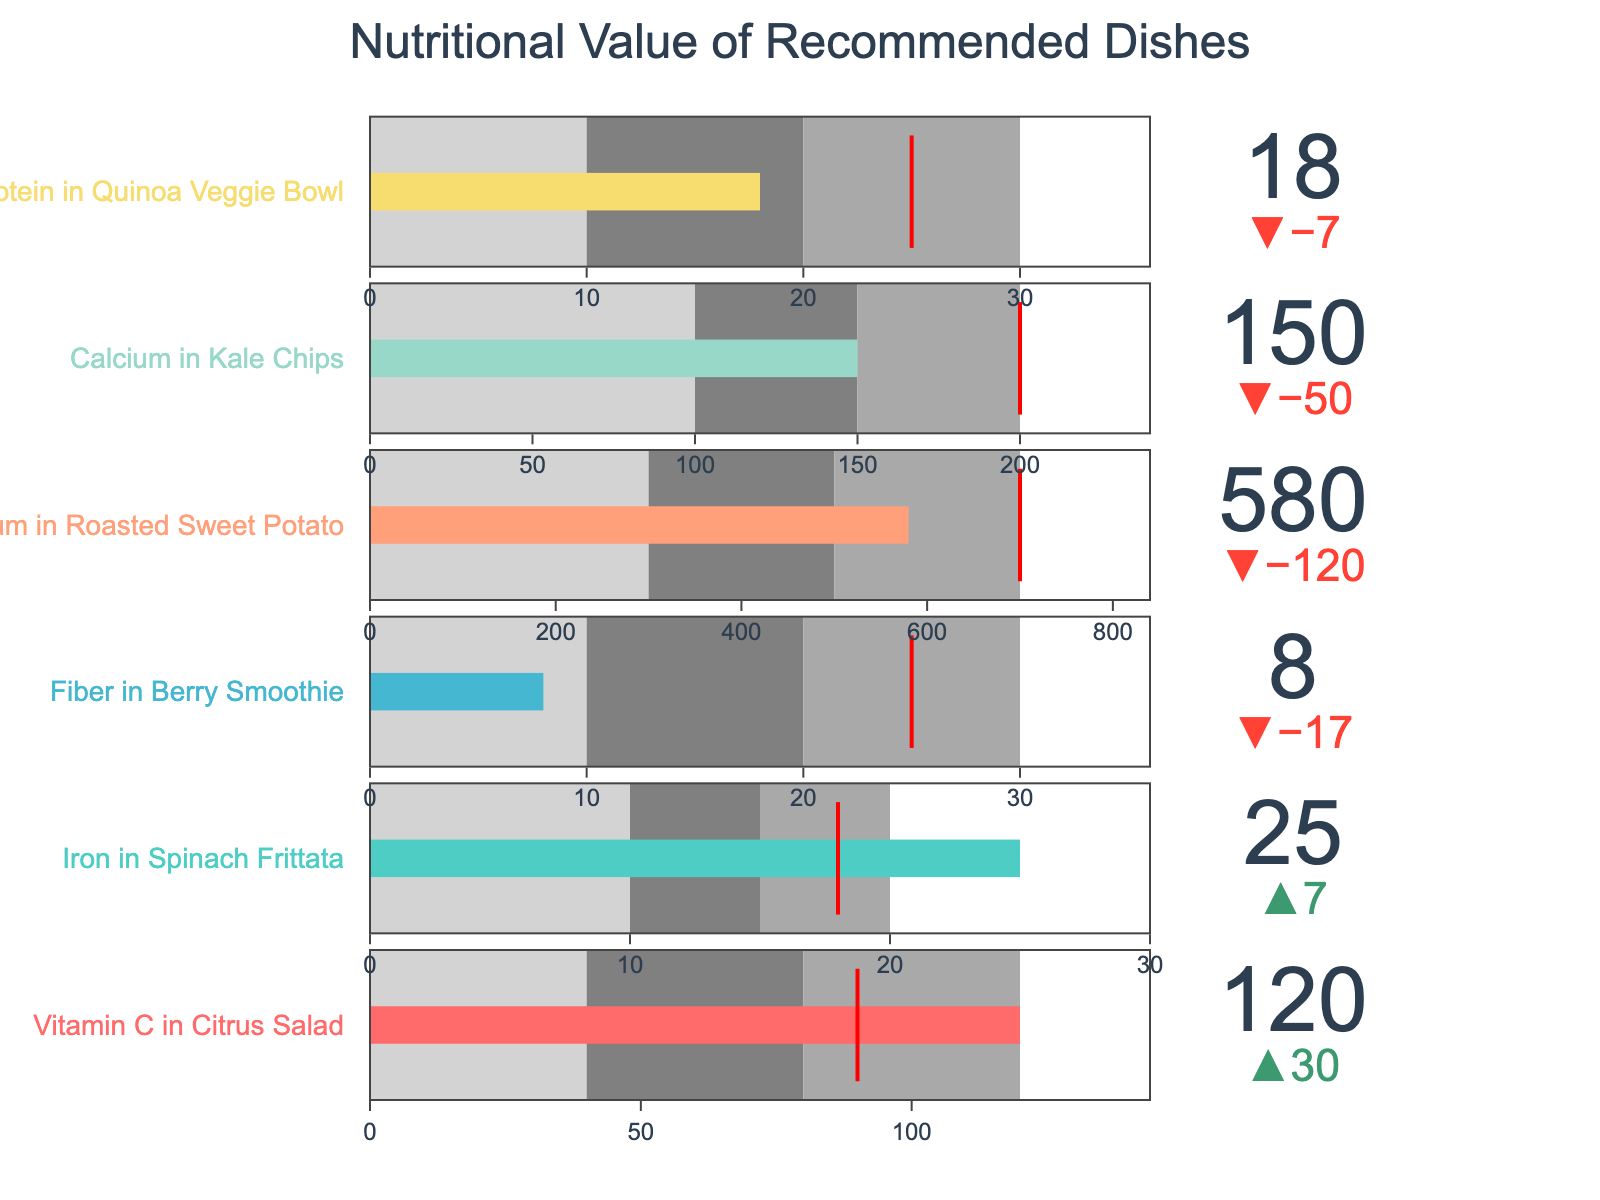What is the title of the chart? The title of the chart is found at the top and it provides an overview of the data being presented.
Answer: Nutritional Value of Recommended Dishes How many recommended dishes are shown in the chart? The number of recommended dishes can be determined by counting the number of bullet charts in the figure. Each bullet chart represents one dish.
Answer: 6 Which dish exceeds its daily recommended target by the greatest amount? You need to observe the delta values or the length of the actual value bar exceeding the target threshold. The dish with the highest positive difference is the answer.
Answer: Vitamin C in Citrus Salad Is the Fiber in Berry Smoothie above or below the target? Look at the delta value or the placement of the actual value bar relative to the target threshold. If the bar is below the threshold, it's below target; vice versa for above.
Answer: Below Which two dishes have the closest actual values? Compare the actual values for each dish shown on the chart and identify the two dishes with the smallest difference between their values.
Answer: Iron in Spinach Frittata, Protein in Quinoa Veggie Bowl What is the target value for Calcium in Kale Chips? Examine the bullet chart for Calcium in Kale Chips and note the red threshold value, which is the target.
Answer: 200 Which dish has the lowest actual nutritional value? Observe all bullet charts and identify the chart with the smallest actual value bar.
Answer: Fiber in Berry Smoothie By how much does the Vitamin C in Citrus Salad exceed its target? Identify the actual value and the target value for Vitamin C in Citrus Salad, then subtract the target from the actual to find the difference. 120 - 90 = 30
Answer: 30 Which dish is the closest to but still below its target value? Look at the delta values of dishes below their targets and find the smallest negative delta.
Answer: Potassium in Roasted Sweet Potato Are any dishes falling short of their targets, if so, which ones? Examine the delta values or the placement of actual value bars relative to targets. Identify all dishes where the actual value bar is below the target threshold.
Answer: Fiber in Berry Smoothie, Potassium in Roasted Sweet Potato, Calcium in Kale Chips, Protein in Quinoa Veggie Bowl 